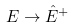Convert formula to latex. <formula><loc_0><loc_0><loc_500><loc_500>E \rightarrow \hat { E } ^ { + }</formula> 